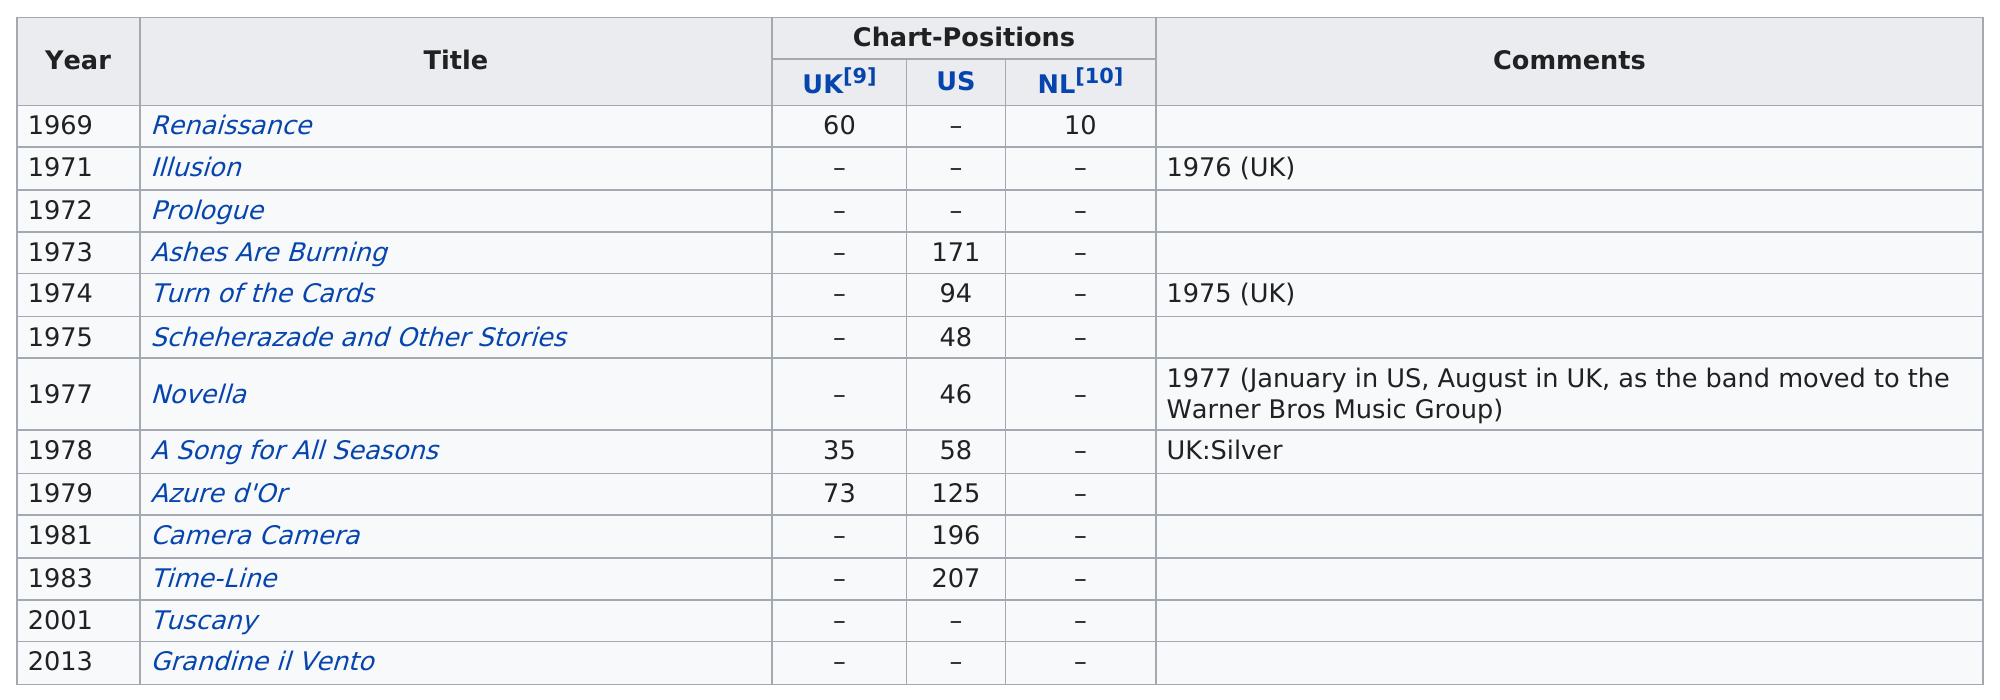Specify some key components in this picture. The earliest album was Renaissance. 